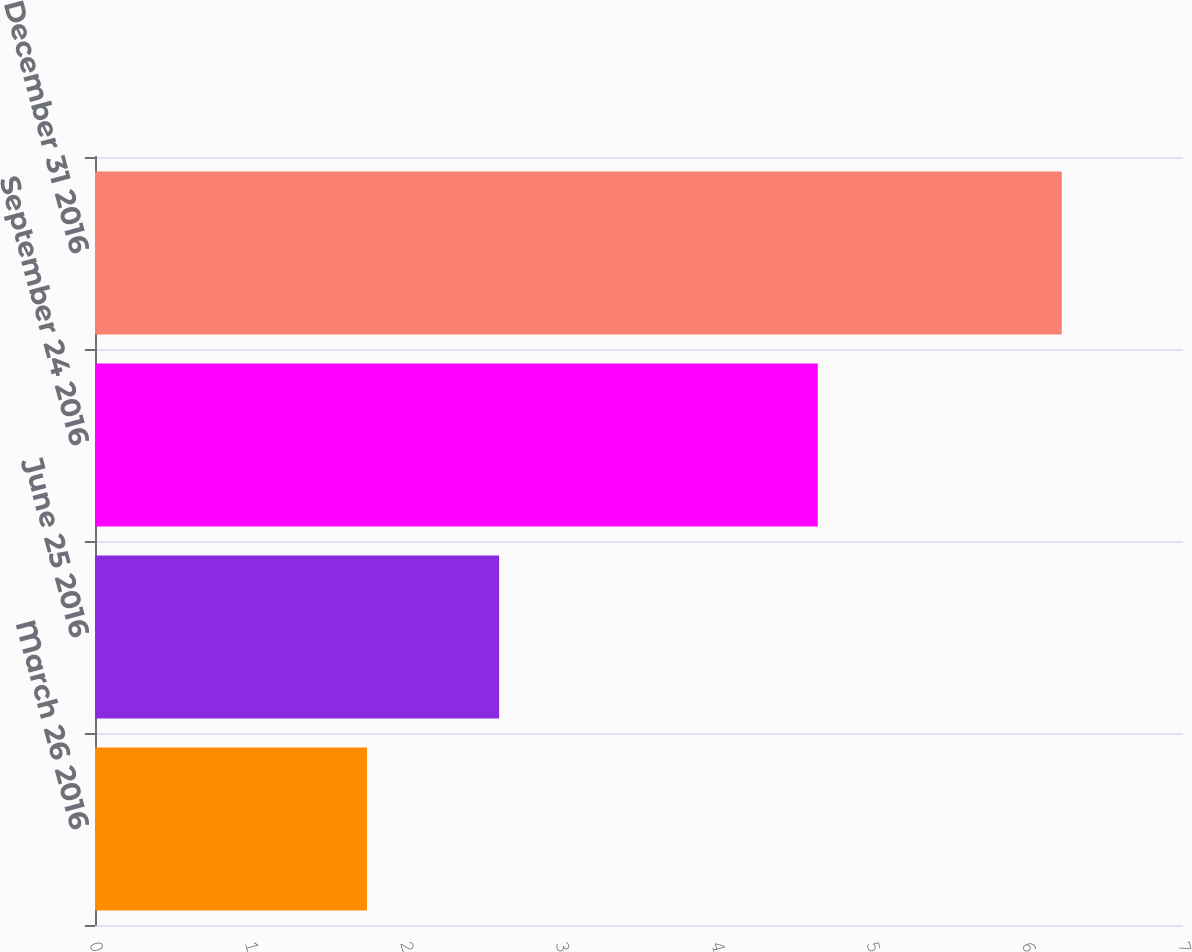Convert chart to OTSL. <chart><loc_0><loc_0><loc_500><loc_500><bar_chart><fcel>March 26 2016<fcel>June 25 2016<fcel>September 24 2016<fcel>December 31 2016<nl><fcel>1.75<fcel>2.6<fcel>4.65<fcel>6.22<nl></chart> 